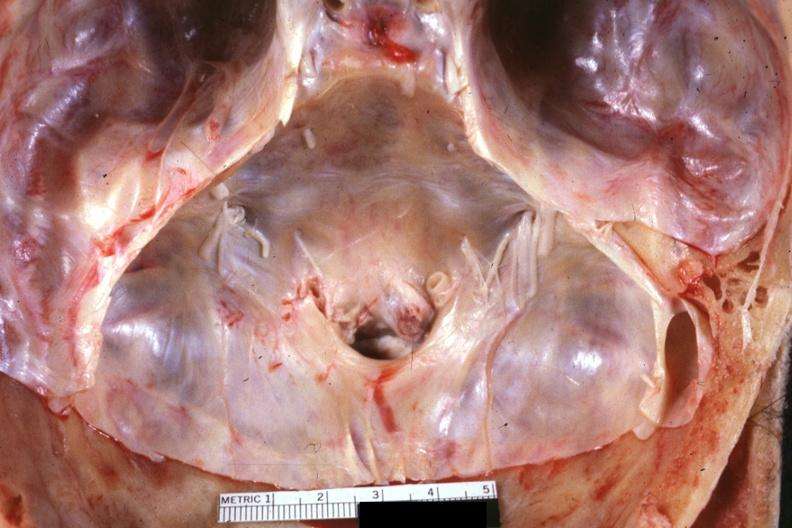s bone, calvarium present?
Answer the question using a single word or phrase. Yes 